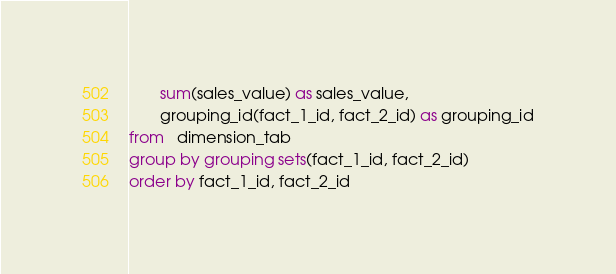Convert code to text. <code><loc_0><loc_0><loc_500><loc_500><_SQL_>       sum(sales_value) as sales_value,
       grouping_id(fact_1_id, fact_2_id) as grouping_id
from   dimension_tab
group by grouping sets(fact_1_id, fact_2_id)
order by fact_1_id, fact_2_id</code> 